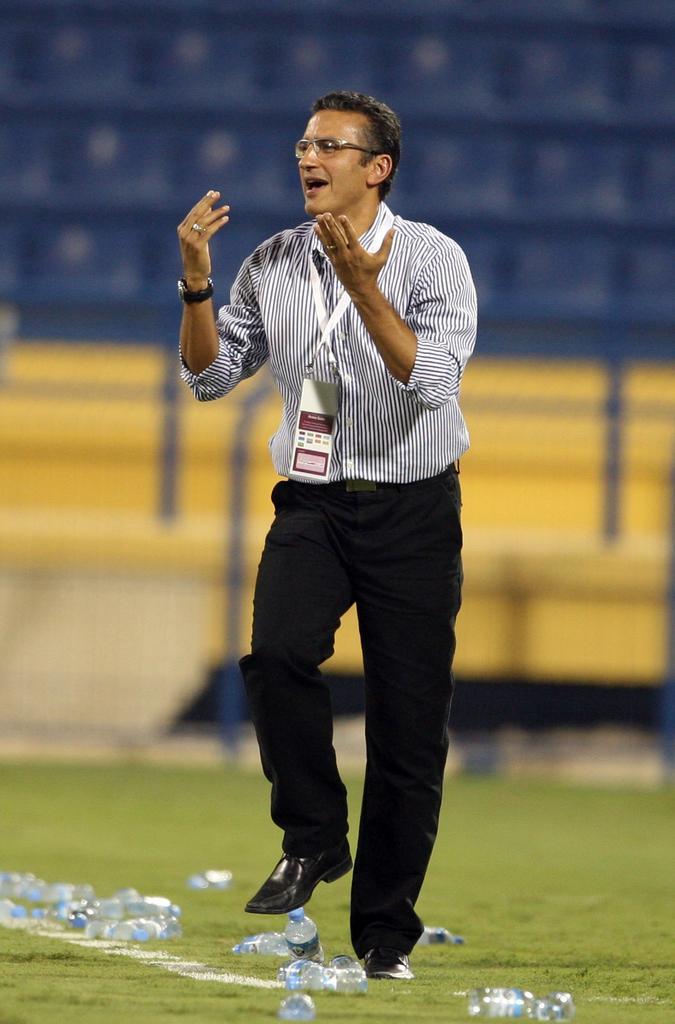Could you give a brief overview of what you see in this image? This is the picture of a stadium. In this image there is a person walking and talking. At the back there are chairs and there is a handrail. At the bottom there are bottles on the grass. 